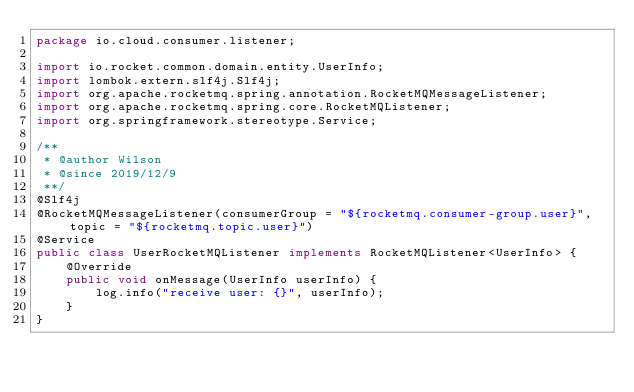Convert code to text. <code><loc_0><loc_0><loc_500><loc_500><_Java_>package io.cloud.consumer.listener;

import io.rocket.common.domain.entity.UserInfo;
import lombok.extern.slf4j.Slf4j;
import org.apache.rocketmq.spring.annotation.RocketMQMessageListener;
import org.apache.rocketmq.spring.core.RocketMQListener;
import org.springframework.stereotype.Service;

/**
 * @author Wilson
 * @since 2019/12/9
 **/
@Slf4j
@RocketMQMessageListener(consumerGroup = "${rocketmq.consumer-group.user}", topic = "${rocketmq.topic.user}")
@Service
public class UserRocketMQListener implements RocketMQListener<UserInfo> {
    @Override
    public void onMessage(UserInfo userInfo) {
        log.info("receive user: {}", userInfo);
    }
}</code> 